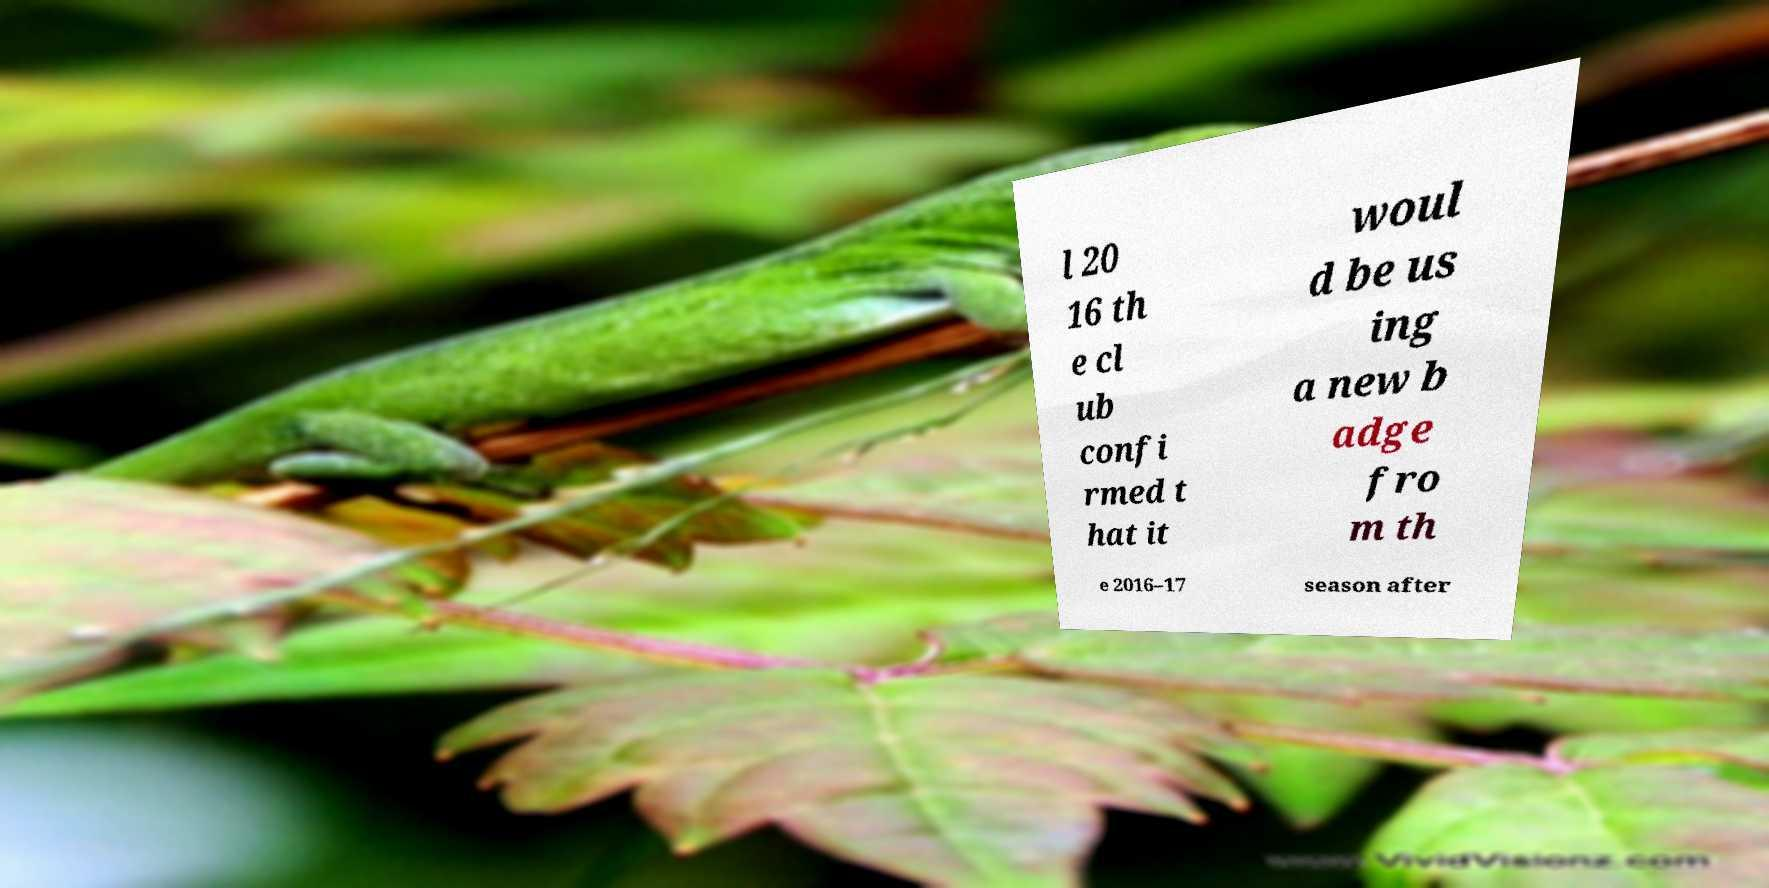Could you assist in decoding the text presented in this image and type it out clearly? l 20 16 th e cl ub confi rmed t hat it woul d be us ing a new b adge fro m th e 2016–17 season after 